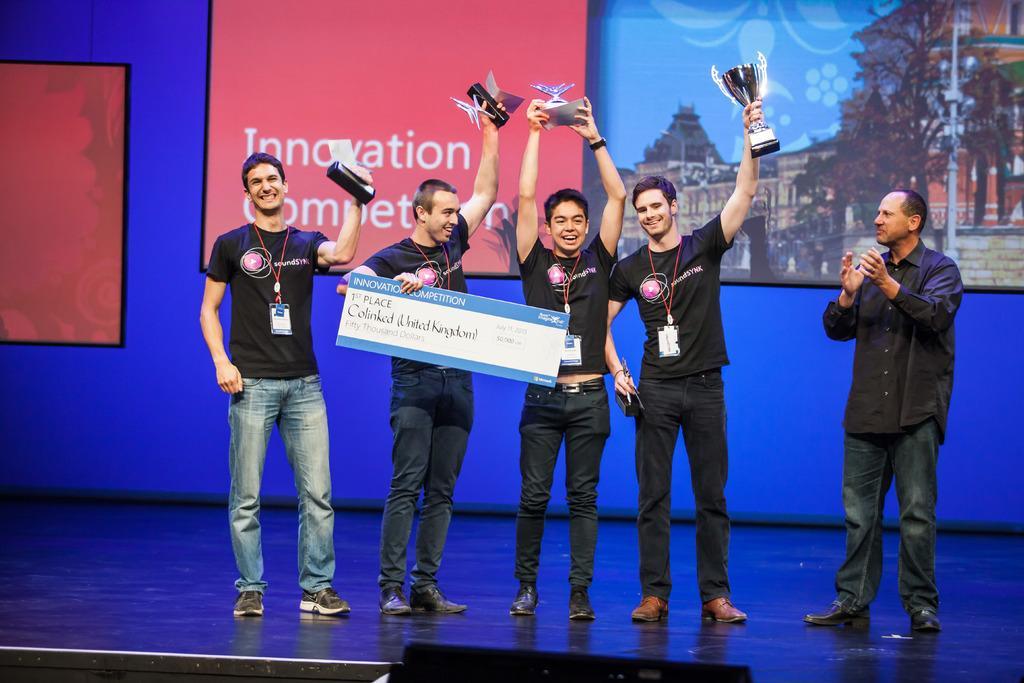In one or two sentences, can you explain what this image depicts? In this image there are five people standing on the dais. There are four people holding trophies and a board. Behind them there is wall. There are boards with pictures and text on the wall. 